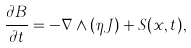Convert formula to latex. <formula><loc_0><loc_0><loc_500><loc_500>\frac { \partial { B } } { \partial t } = - \nabla \wedge ( \eta { J } ) + S ( { x } , t ) ,</formula> 